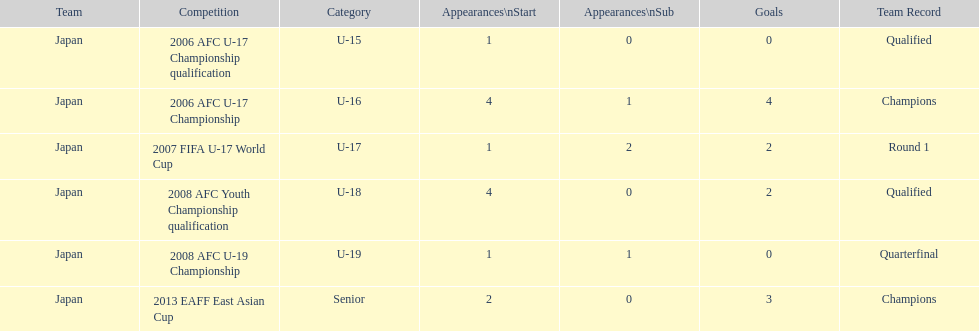How many total goals were scored? 11. 